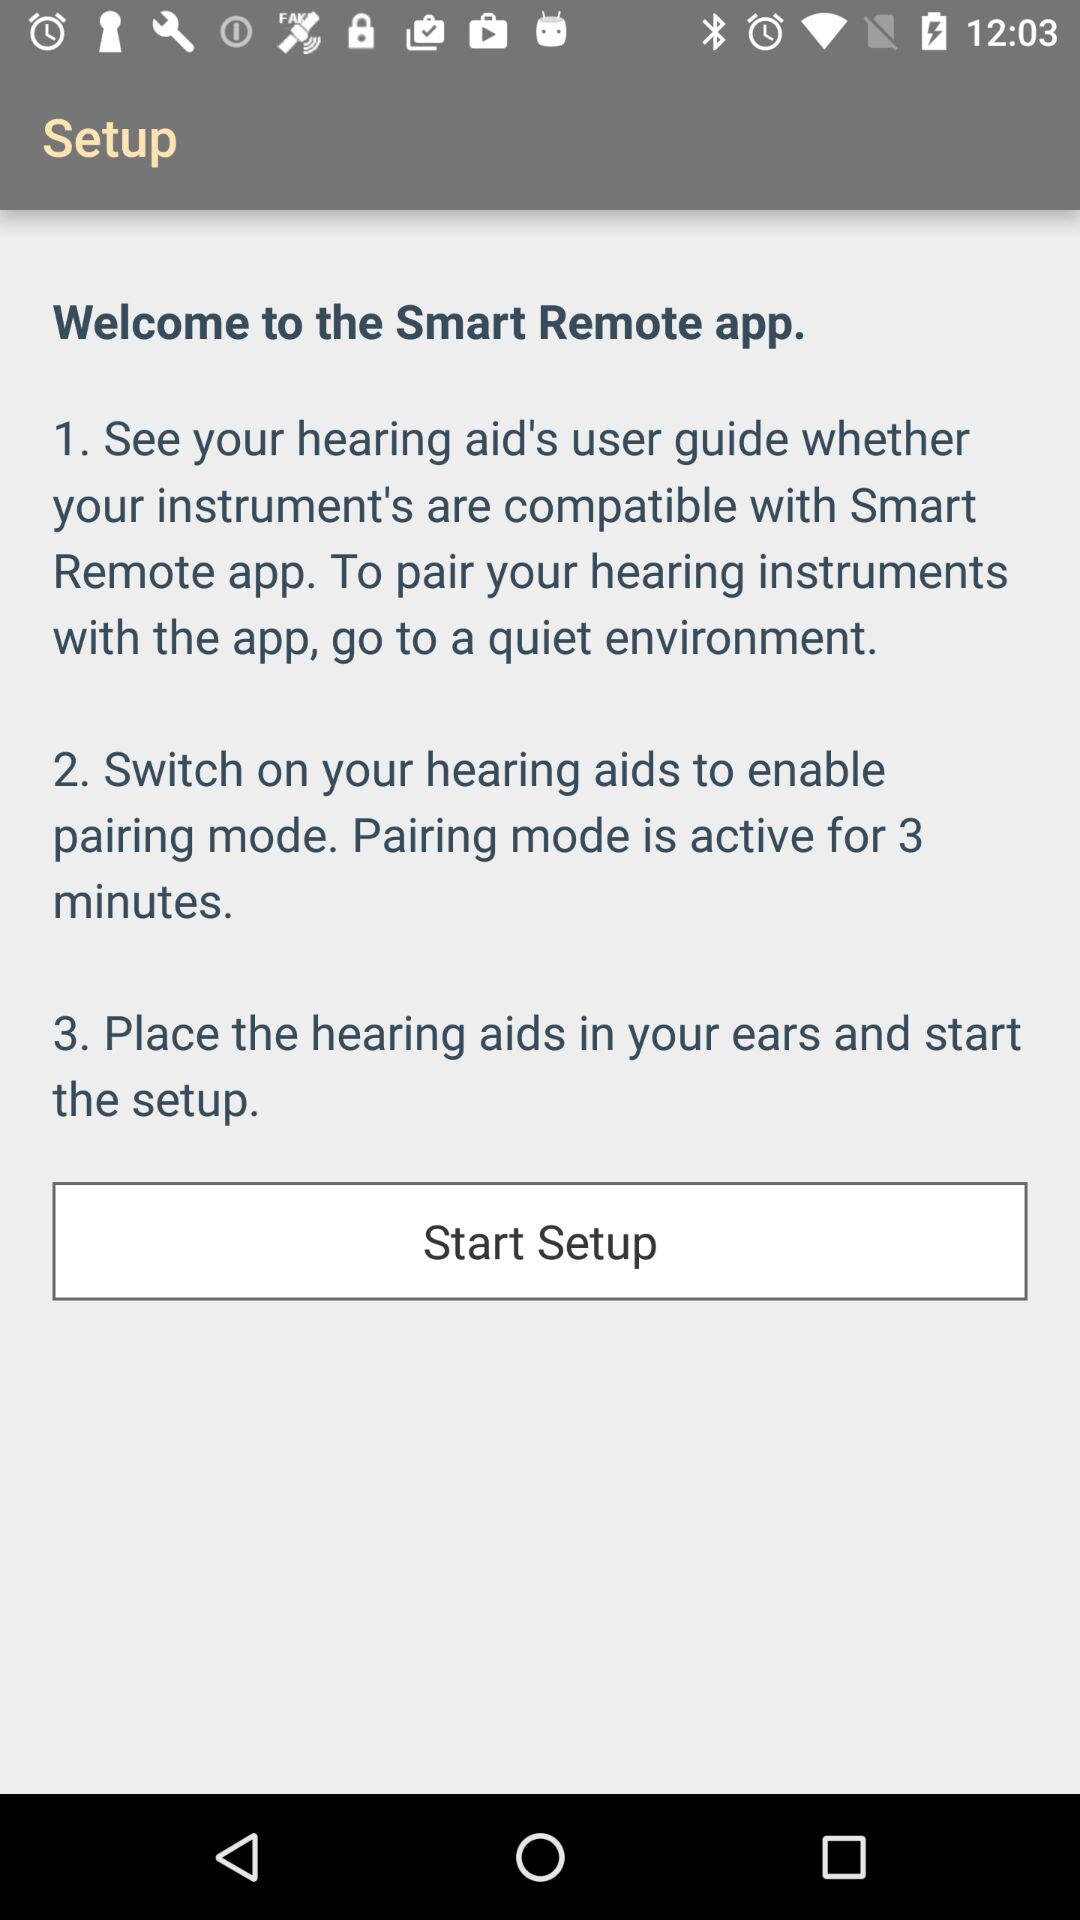For how many minutes does pairing mode remain active? Pairing mode remains active for 3 minutes. 